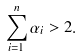<formula> <loc_0><loc_0><loc_500><loc_500>\sum _ { i = 1 } ^ { n } \alpha _ { i } > 2 .</formula> 